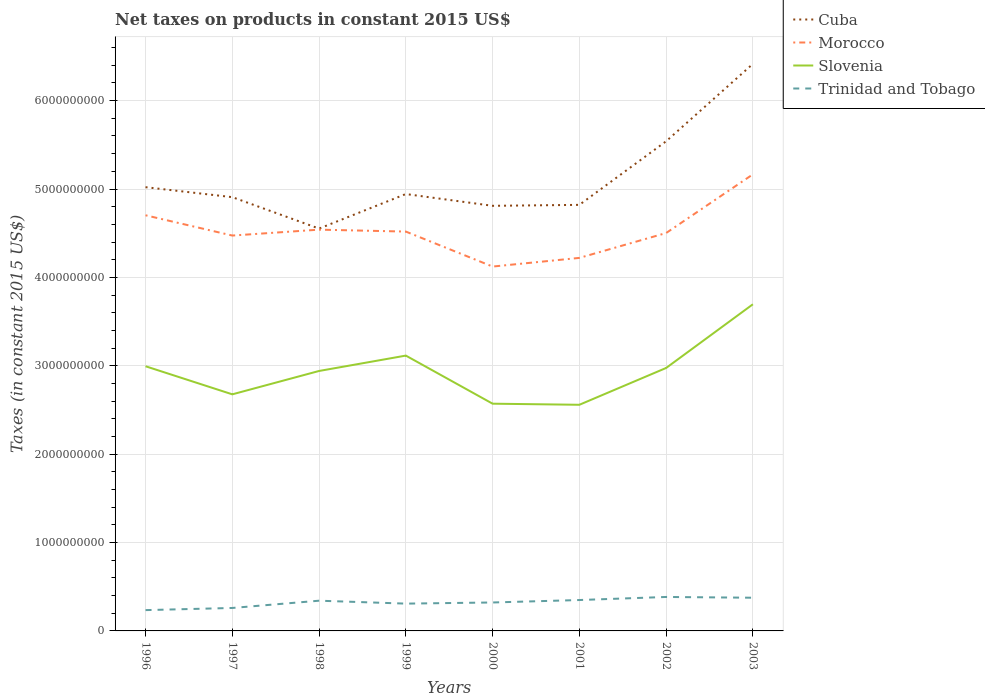How many different coloured lines are there?
Make the answer very short. 4. Does the line corresponding to Cuba intersect with the line corresponding to Trinidad and Tobago?
Ensure brevity in your answer.  No. Across all years, what is the maximum net taxes on products in Morocco?
Offer a very short reply. 4.12e+09. In which year was the net taxes on products in Slovenia maximum?
Your response must be concise. 2001. What is the total net taxes on products in Trinidad and Tobago in the graph?
Offer a terse response. -4.92e+07. What is the difference between the highest and the second highest net taxes on products in Trinidad and Tobago?
Offer a very short reply. 1.49e+08. Is the net taxes on products in Trinidad and Tobago strictly greater than the net taxes on products in Cuba over the years?
Your answer should be very brief. Yes. What is the difference between two consecutive major ticks on the Y-axis?
Provide a succinct answer. 1.00e+09. Are the values on the major ticks of Y-axis written in scientific E-notation?
Offer a terse response. No. Does the graph contain any zero values?
Your answer should be very brief. No. What is the title of the graph?
Your response must be concise. Net taxes on products in constant 2015 US$. Does "Korea (Republic)" appear as one of the legend labels in the graph?
Offer a terse response. No. What is the label or title of the X-axis?
Your answer should be very brief. Years. What is the label or title of the Y-axis?
Offer a terse response. Taxes (in constant 2015 US$). What is the Taxes (in constant 2015 US$) of Cuba in 1996?
Your answer should be very brief. 5.02e+09. What is the Taxes (in constant 2015 US$) of Morocco in 1996?
Your answer should be compact. 4.70e+09. What is the Taxes (in constant 2015 US$) in Slovenia in 1996?
Make the answer very short. 2.99e+09. What is the Taxes (in constant 2015 US$) of Trinidad and Tobago in 1996?
Make the answer very short. 2.35e+08. What is the Taxes (in constant 2015 US$) of Cuba in 1997?
Keep it short and to the point. 4.91e+09. What is the Taxes (in constant 2015 US$) of Morocco in 1997?
Provide a succinct answer. 4.47e+09. What is the Taxes (in constant 2015 US$) of Slovenia in 1997?
Offer a very short reply. 2.68e+09. What is the Taxes (in constant 2015 US$) of Trinidad and Tobago in 1997?
Ensure brevity in your answer.  2.60e+08. What is the Taxes (in constant 2015 US$) of Cuba in 1998?
Provide a short and direct response. 4.55e+09. What is the Taxes (in constant 2015 US$) of Morocco in 1998?
Provide a succinct answer. 4.54e+09. What is the Taxes (in constant 2015 US$) of Slovenia in 1998?
Give a very brief answer. 2.94e+09. What is the Taxes (in constant 2015 US$) of Trinidad and Tobago in 1998?
Provide a succinct answer. 3.42e+08. What is the Taxes (in constant 2015 US$) in Cuba in 1999?
Offer a very short reply. 4.94e+09. What is the Taxes (in constant 2015 US$) of Morocco in 1999?
Give a very brief answer. 4.52e+09. What is the Taxes (in constant 2015 US$) in Slovenia in 1999?
Your response must be concise. 3.12e+09. What is the Taxes (in constant 2015 US$) in Trinidad and Tobago in 1999?
Offer a very short reply. 3.09e+08. What is the Taxes (in constant 2015 US$) of Cuba in 2000?
Give a very brief answer. 4.81e+09. What is the Taxes (in constant 2015 US$) in Morocco in 2000?
Your response must be concise. 4.12e+09. What is the Taxes (in constant 2015 US$) in Slovenia in 2000?
Ensure brevity in your answer.  2.57e+09. What is the Taxes (in constant 2015 US$) in Trinidad and Tobago in 2000?
Give a very brief answer. 3.22e+08. What is the Taxes (in constant 2015 US$) in Cuba in 2001?
Provide a succinct answer. 4.82e+09. What is the Taxes (in constant 2015 US$) of Morocco in 2001?
Provide a succinct answer. 4.22e+09. What is the Taxes (in constant 2015 US$) of Slovenia in 2001?
Give a very brief answer. 2.56e+09. What is the Taxes (in constant 2015 US$) of Trinidad and Tobago in 2001?
Ensure brevity in your answer.  3.50e+08. What is the Taxes (in constant 2015 US$) in Cuba in 2002?
Your answer should be very brief. 5.54e+09. What is the Taxes (in constant 2015 US$) in Morocco in 2002?
Keep it short and to the point. 4.50e+09. What is the Taxes (in constant 2015 US$) of Slovenia in 2002?
Make the answer very short. 2.98e+09. What is the Taxes (in constant 2015 US$) of Trinidad and Tobago in 2002?
Make the answer very short. 3.84e+08. What is the Taxes (in constant 2015 US$) of Cuba in 2003?
Offer a very short reply. 6.42e+09. What is the Taxes (in constant 2015 US$) of Morocco in 2003?
Your answer should be very brief. 5.17e+09. What is the Taxes (in constant 2015 US$) in Slovenia in 2003?
Give a very brief answer. 3.70e+09. What is the Taxes (in constant 2015 US$) of Trinidad and Tobago in 2003?
Offer a terse response. 3.76e+08. Across all years, what is the maximum Taxes (in constant 2015 US$) in Cuba?
Offer a terse response. 6.42e+09. Across all years, what is the maximum Taxes (in constant 2015 US$) in Morocco?
Offer a very short reply. 5.17e+09. Across all years, what is the maximum Taxes (in constant 2015 US$) in Slovenia?
Ensure brevity in your answer.  3.70e+09. Across all years, what is the maximum Taxes (in constant 2015 US$) of Trinidad and Tobago?
Provide a succinct answer. 3.84e+08. Across all years, what is the minimum Taxes (in constant 2015 US$) in Cuba?
Give a very brief answer. 4.55e+09. Across all years, what is the minimum Taxes (in constant 2015 US$) in Morocco?
Offer a terse response. 4.12e+09. Across all years, what is the minimum Taxes (in constant 2015 US$) in Slovenia?
Keep it short and to the point. 2.56e+09. Across all years, what is the minimum Taxes (in constant 2015 US$) in Trinidad and Tobago?
Your answer should be very brief. 2.35e+08. What is the total Taxes (in constant 2015 US$) in Cuba in the graph?
Your response must be concise. 4.10e+1. What is the total Taxes (in constant 2015 US$) in Morocco in the graph?
Offer a terse response. 3.62e+1. What is the total Taxes (in constant 2015 US$) of Slovenia in the graph?
Offer a very short reply. 2.35e+1. What is the total Taxes (in constant 2015 US$) in Trinidad and Tobago in the graph?
Offer a terse response. 2.58e+09. What is the difference between the Taxes (in constant 2015 US$) in Cuba in 1996 and that in 1997?
Your response must be concise. 1.13e+08. What is the difference between the Taxes (in constant 2015 US$) in Morocco in 1996 and that in 1997?
Offer a very short reply. 2.29e+08. What is the difference between the Taxes (in constant 2015 US$) in Slovenia in 1996 and that in 1997?
Your answer should be compact. 3.18e+08. What is the difference between the Taxes (in constant 2015 US$) in Trinidad and Tobago in 1996 and that in 1997?
Make the answer very short. -2.43e+07. What is the difference between the Taxes (in constant 2015 US$) in Cuba in 1996 and that in 1998?
Provide a succinct answer. 4.68e+08. What is the difference between the Taxes (in constant 2015 US$) in Morocco in 1996 and that in 1998?
Keep it short and to the point. 1.63e+08. What is the difference between the Taxes (in constant 2015 US$) in Slovenia in 1996 and that in 1998?
Offer a very short reply. 5.34e+07. What is the difference between the Taxes (in constant 2015 US$) in Trinidad and Tobago in 1996 and that in 1998?
Provide a short and direct response. -1.07e+08. What is the difference between the Taxes (in constant 2015 US$) of Cuba in 1996 and that in 1999?
Your answer should be compact. 7.76e+07. What is the difference between the Taxes (in constant 2015 US$) in Morocco in 1996 and that in 1999?
Give a very brief answer. 1.85e+08. What is the difference between the Taxes (in constant 2015 US$) of Slovenia in 1996 and that in 1999?
Your response must be concise. -1.21e+08. What is the difference between the Taxes (in constant 2015 US$) in Trinidad and Tobago in 1996 and that in 1999?
Make the answer very short. -7.35e+07. What is the difference between the Taxes (in constant 2015 US$) in Cuba in 1996 and that in 2000?
Your answer should be compact. 2.11e+08. What is the difference between the Taxes (in constant 2015 US$) in Morocco in 1996 and that in 2000?
Your answer should be very brief. 5.80e+08. What is the difference between the Taxes (in constant 2015 US$) in Slovenia in 1996 and that in 2000?
Provide a short and direct response. 4.24e+08. What is the difference between the Taxes (in constant 2015 US$) of Trinidad and Tobago in 1996 and that in 2000?
Give a very brief answer. -8.63e+07. What is the difference between the Taxes (in constant 2015 US$) of Cuba in 1996 and that in 2001?
Offer a very short reply. 2.00e+08. What is the difference between the Taxes (in constant 2015 US$) of Morocco in 1996 and that in 2001?
Offer a terse response. 4.82e+08. What is the difference between the Taxes (in constant 2015 US$) of Slovenia in 1996 and that in 2001?
Offer a very short reply. 4.36e+08. What is the difference between the Taxes (in constant 2015 US$) of Trinidad and Tobago in 1996 and that in 2001?
Your response must be concise. -1.14e+08. What is the difference between the Taxes (in constant 2015 US$) of Cuba in 1996 and that in 2002?
Provide a succinct answer. -5.19e+08. What is the difference between the Taxes (in constant 2015 US$) of Morocco in 1996 and that in 2002?
Your answer should be compact. 2.01e+08. What is the difference between the Taxes (in constant 2015 US$) in Slovenia in 1996 and that in 2002?
Offer a terse response. 1.95e+07. What is the difference between the Taxes (in constant 2015 US$) of Trinidad and Tobago in 1996 and that in 2002?
Make the answer very short. -1.49e+08. What is the difference between the Taxes (in constant 2015 US$) of Cuba in 1996 and that in 2003?
Your answer should be compact. -1.40e+09. What is the difference between the Taxes (in constant 2015 US$) in Morocco in 1996 and that in 2003?
Keep it short and to the point. -4.63e+08. What is the difference between the Taxes (in constant 2015 US$) in Slovenia in 1996 and that in 2003?
Keep it short and to the point. -7.01e+08. What is the difference between the Taxes (in constant 2015 US$) of Trinidad and Tobago in 1996 and that in 2003?
Ensure brevity in your answer.  -1.40e+08. What is the difference between the Taxes (in constant 2015 US$) in Cuba in 1997 and that in 1998?
Your answer should be compact. 3.56e+08. What is the difference between the Taxes (in constant 2015 US$) in Morocco in 1997 and that in 1998?
Your response must be concise. -6.67e+07. What is the difference between the Taxes (in constant 2015 US$) in Slovenia in 1997 and that in 1998?
Make the answer very short. -2.64e+08. What is the difference between the Taxes (in constant 2015 US$) of Trinidad and Tobago in 1997 and that in 1998?
Your answer should be compact. -8.22e+07. What is the difference between the Taxes (in constant 2015 US$) of Cuba in 1997 and that in 1999?
Offer a very short reply. -3.52e+07. What is the difference between the Taxes (in constant 2015 US$) in Morocco in 1997 and that in 1999?
Give a very brief answer. -4.49e+07. What is the difference between the Taxes (in constant 2015 US$) in Slovenia in 1997 and that in 1999?
Your answer should be very brief. -4.38e+08. What is the difference between the Taxes (in constant 2015 US$) of Trinidad and Tobago in 1997 and that in 1999?
Give a very brief answer. -4.92e+07. What is the difference between the Taxes (in constant 2015 US$) in Cuba in 1997 and that in 2000?
Your answer should be very brief. 9.80e+07. What is the difference between the Taxes (in constant 2015 US$) in Morocco in 1997 and that in 2000?
Offer a very short reply. 3.51e+08. What is the difference between the Taxes (in constant 2015 US$) in Slovenia in 1997 and that in 2000?
Your answer should be very brief. 1.06e+08. What is the difference between the Taxes (in constant 2015 US$) in Trinidad and Tobago in 1997 and that in 2000?
Provide a short and direct response. -6.20e+07. What is the difference between the Taxes (in constant 2015 US$) in Cuba in 1997 and that in 2001?
Provide a short and direct response. 8.72e+07. What is the difference between the Taxes (in constant 2015 US$) in Morocco in 1997 and that in 2001?
Make the answer very short. 2.53e+08. What is the difference between the Taxes (in constant 2015 US$) in Slovenia in 1997 and that in 2001?
Your answer should be very brief. 1.18e+08. What is the difference between the Taxes (in constant 2015 US$) of Trinidad and Tobago in 1997 and that in 2001?
Your answer should be compact. -8.98e+07. What is the difference between the Taxes (in constant 2015 US$) in Cuba in 1997 and that in 2002?
Offer a terse response. -6.32e+08. What is the difference between the Taxes (in constant 2015 US$) of Morocco in 1997 and that in 2002?
Offer a very short reply. -2.85e+07. What is the difference between the Taxes (in constant 2015 US$) of Slovenia in 1997 and that in 2002?
Give a very brief answer. -2.98e+08. What is the difference between the Taxes (in constant 2015 US$) of Trinidad and Tobago in 1997 and that in 2002?
Provide a short and direct response. -1.24e+08. What is the difference between the Taxes (in constant 2015 US$) of Cuba in 1997 and that in 2003?
Offer a very short reply. -1.51e+09. What is the difference between the Taxes (in constant 2015 US$) in Morocco in 1997 and that in 2003?
Give a very brief answer. -6.92e+08. What is the difference between the Taxes (in constant 2015 US$) in Slovenia in 1997 and that in 2003?
Keep it short and to the point. -1.02e+09. What is the difference between the Taxes (in constant 2015 US$) of Trinidad and Tobago in 1997 and that in 2003?
Offer a very short reply. -1.16e+08. What is the difference between the Taxes (in constant 2015 US$) in Cuba in 1998 and that in 1999?
Your answer should be very brief. -3.91e+08. What is the difference between the Taxes (in constant 2015 US$) of Morocco in 1998 and that in 1999?
Your answer should be compact. 2.18e+07. What is the difference between the Taxes (in constant 2015 US$) in Slovenia in 1998 and that in 1999?
Provide a succinct answer. -1.74e+08. What is the difference between the Taxes (in constant 2015 US$) of Trinidad and Tobago in 1998 and that in 1999?
Provide a succinct answer. 3.30e+07. What is the difference between the Taxes (in constant 2015 US$) of Cuba in 1998 and that in 2000?
Offer a terse response. -2.58e+08. What is the difference between the Taxes (in constant 2015 US$) of Morocco in 1998 and that in 2000?
Offer a terse response. 4.18e+08. What is the difference between the Taxes (in constant 2015 US$) in Slovenia in 1998 and that in 2000?
Your response must be concise. 3.70e+08. What is the difference between the Taxes (in constant 2015 US$) in Trinidad and Tobago in 1998 and that in 2000?
Provide a succinct answer. 2.02e+07. What is the difference between the Taxes (in constant 2015 US$) in Cuba in 1998 and that in 2001?
Offer a very short reply. -2.68e+08. What is the difference between the Taxes (in constant 2015 US$) in Morocco in 1998 and that in 2001?
Make the answer very short. 3.20e+08. What is the difference between the Taxes (in constant 2015 US$) in Slovenia in 1998 and that in 2001?
Offer a terse response. 3.83e+08. What is the difference between the Taxes (in constant 2015 US$) of Trinidad and Tobago in 1998 and that in 2001?
Offer a terse response. -7.55e+06. What is the difference between the Taxes (in constant 2015 US$) in Cuba in 1998 and that in 2002?
Your answer should be compact. -9.88e+08. What is the difference between the Taxes (in constant 2015 US$) of Morocco in 1998 and that in 2002?
Keep it short and to the point. 3.82e+07. What is the difference between the Taxes (in constant 2015 US$) in Slovenia in 1998 and that in 2002?
Your response must be concise. -3.40e+07. What is the difference between the Taxes (in constant 2015 US$) of Trinidad and Tobago in 1998 and that in 2002?
Ensure brevity in your answer.  -4.22e+07. What is the difference between the Taxes (in constant 2015 US$) of Cuba in 1998 and that in 2003?
Make the answer very short. -1.86e+09. What is the difference between the Taxes (in constant 2015 US$) in Morocco in 1998 and that in 2003?
Your answer should be very brief. -6.26e+08. What is the difference between the Taxes (in constant 2015 US$) in Slovenia in 1998 and that in 2003?
Give a very brief answer. -7.55e+08. What is the difference between the Taxes (in constant 2015 US$) of Trinidad and Tobago in 1998 and that in 2003?
Give a very brief answer. -3.36e+07. What is the difference between the Taxes (in constant 2015 US$) of Cuba in 1999 and that in 2000?
Your answer should be very brief. 1.33e+08. What is the difference between the Taxes (in constant 2015 US$) of Morocco in 1999 and that in 2000?
Your answer should be very brief. 3.96e+08. What is the difference between the Taxes (in constant 2015 US$) of Slovenia in 1999 and that in 2000?
Provide a short and direct response. 5.44e+08. What is the difference between the Taxes (in constant 2015 US$) of Trinidad and Tobago in 1999 and that in 2000?
Provide a succinct answer. -1.29e+07. What is the difference between the Taxes (in constant 2015 US$) of Cuba in 1999 and that in 2001?
Keep it short and to the point. 1.22e+08. What is the difference between the Taxes (in constant 2015 US$) in Morocco in 1999 and that in 2001?
Your response must be concise. 2.98e+08. What is the difference between the Taxes (in constant 2015 US$) of Slovenia in 1999 and that in 2001?
Your answer should be very brief. 5.56e+08. What is the difference between the Taxes (in constant 2015 US$) of Trinidad and Tobago in 1999 and that in 2001?
Make the answer very short. -4.06e+07. What is the difference between the Taxes (in constant 2015 US$) in Cuba in 1999 and that in 2002?
Keep it short and to the point. -5.97e+08. What is the difference between the Taxes (in constant 2015 US$) of Morocco in 1999 and that in 2002?
Offer a terse response. 1.64e+07. What is the difference between the Taxes (in constant 2015 US$) of Slovenia in 1999 and that in 2002?
Make the answer very short. 1.40e+08. What is the difference between the Taxes (in constant 2015 US$) of Trinidad and Tobago in 1999 and that in 2002?
Your answer should be very brief. -7.53e+07. What is the difference between the Taxes (in constant 2015 US$) in Cuba in 1999 and that in 2003?
Your answer should be very brief. -1.47e+09. What is the difference between the Taxes (in constant 2015 US$) of Morocco in 1999 and that in 2003?
Keep it short and to the point. -6.48e+08. What is the difference between the Taxes (in constant 2015 US$) in Slovenia in 1999 and that in 2003?
Make the answer very short. -5.81e+08. What is the difference between the Taxes (in constant 2015 US$) in Trinidad and Tobago in 1999 and that in 2003?
Your response must be concise. -6.66e+07. What is the difference between the Taxes (in constant 2015 US$) of Cuba in 2000 and that in 2001?
Make the answer very short. -1.08e+07. What is the difference between the Taxes (in constant 2015 US$) in Morocco in 2000 and that in 2001?
Your answer should be compact. -9.79e+07. What is the difference between the Taxes (in constant 2015 US$) in Slovenia in 2000 and that in 2001?
Offer a terse response. 1.23e+07. What is the difference between the Taxes (in constant 2015 US$) in Trinidad and Tobago in 2000 and that in 2001?
Provide a short and direct response. -2.77e+07. What is the difference between the Taxes (in constant 2015 US$) of Cuba in 2000 and that in 2002?
Your response must be concise. -7.30e+08. What is the difference between the Taxes (in constant 2015 US$) of Morocco in 2000 and that in 2002?
Ensure brevity in your answer.  -3.79e+08. What is the difference between the Taxes (in constant 2015 US$) in Slovenia in 2000 and that in 2002?
Offer a very short reply. -4.04e+08. What is the difference between the Taxes (in constant 2015 US$) in Trinidad and Tobago in 2000 and that in 2002?
Ensure brevity in your answer.  -6.24e+07. What is the difference between the Taxes (in constant 2015 US$) in Cuba in 2000 and that in 2003?
Your answer should be very brief. -1.61e+09. What is the difference between the Taxes (in constant 2015 US$) of Morocco in 2000 and that in 2003?
Provide a short and direct response. -1.04e+09. What is the difference between the Taxes (in constant 2015 US$) in Slovenia in 2000 and that in 2003?
Give a very brief answer. -1.12e+09. What is the difference between the Taxes (in constant 2015 US$) in Trinidad and Tobago in 2000 and that in 2003?
Your answer should be compact. -5.38e+07. What is the difference between the Taxes (in constant 2015 US$) of Cuba in 2001 and that in 2002?
Make the answer very short. -7.19e+08. What is the difference between the Taxes (in constant 2015 US$) of Morocco in 2001 and that in 2002?
Keep it short and to the point. -2.81e+08. What is the difference between the Taxes (in constant 2015 US$) in Slovenia in 2001 and that in 2002?
Make the answer very short. -4.16e+08. What is the difference between the Taxes (in constant 2015 US$) of Trinidad and Tobago in 2001 and that in 2002?
Provide a succinct answer. -3.47e+07. What is the difference between the Taxes (in constant 2015 US$) of Cuba in 2001 and that in 2003?
Offer a terse response. -1.60e+09. What is the difference between the Taxes (in constant 2015 US$) of Morocco in 2001 and that in 2003?
Provide a short and direct response. -9.45e+08. What is the difference between the Taxes (in constant 2015 US$) of Slovenia in 2001 and that in 2003?
Provide a succinct answer. -1.14e+09. What is the difference between the Taxes (in constant 2015 US$) in Trinidad and Tobago in 2001 and that in 2003?
Ensure brevity in your answer.  -2.60e+07. What is the difference between the Taxes (in constant 2015 US$) of Cuba in 2002 and that in 2003?
Provide a short and direct response. -8.76e+08. What is the difference between the Taxes (in constant 2015 US$) of Morocco in 2002 and that in 2003?
Offer a very short reply. -6.64e+08. What is the difference between the Taxes (in constant 2015 US$) of Slovenia in 2002 and that in 2003?
Provide a succinct answer. -7.21e+08. What is the difference between the Taxes (in constant 2015 US$) of Trinidad and Tobago in 2002 and that in 2003?
Give a very brief answer. 8.65e+06. What is the difference between the Taxes (in constant 2015 US$) of Cuba in 1996 and the Taxes (in constant 2015 US$) of Morocco in 1997?
Your response must be concise. 5.47e+08. What is the difference between the Taxes (in constant 2015 US$) in Cuba in 1996 and the Taxes (in constant 2015 US$) in Slovenia in 1997?
Keep it short and to the point. 2.34e+09. What is the difference between the Taxes (in constant 2015 US$) of Cuba in 1996 and the Taxes (in constant 2015 US$) of Trinidad and Tobago in 1997?
Provide a short and direct response. 4.76e+09. What is the difference between the Taxes (in constant 2015 US$) of Morocco in 1996 and the Taxes (in constant 2015 US$) of Slovenia in 1997?
Your answer should be compact. 2.03e+09. What is the difference between the Taxes (in constant 2015 US$) in Morocco in 1996 and the Taxes (in constant 2015 US$) in Trinidad and Tobago in 1997?
Ensure brevity in your answer.  4.44e+09. What is the difference between the Taxes (in constant 2015 US$) of Slovenia in 1996 and the Taxes (in constant 2015 US$) of Trinidad and Tobago in 1997?
Provide a short and direct response. 2.73e+09. What is the difference between the Taxes (in constant 2015 US$) in Cuba in 1996 and the Taxes (in constant 2015 US$) in Morocco in 1998?
Ensure brevity in your answer.  4.80e+08. What is the difference between the Taxes (in constant 2015 US$) in Cuba in 1996 and the Taxes (in constant 2015 US$) in Slovenia in 1998?
Provide a succinct answer. 2.08e+09. What is the difference between the Taxes (in constant 2015 US$) of Cuba in 1996 and the Taxes (in constant 2015 US$) of Trinidad and Tobago in 1998?
Your answer should be compact. 4.68e+09. What is the difference between the Taxes (in constant 2015 US$) in Morocco in 1996 and the Taxes (in constant 2015 US$) in Slovenia in 1998?
Give a very brief answer. 1.76e+09. What is the difference between the Taxes (in constant 2015 US$) in Morocco in 1996 and the Taxes (in constant 2015 US$) in Trinidad and Tobago in 1998?
Provide a succinct answer. 4.36e+09. What is the difference between the Taxes (in constant 2015 US$) of Slovenia in 1996 and the Taxes (in constant 2015 US$) of Trinidad and Tobago in 1998?
Offer a very short reply. 2.65e+09. What is the difference between the Taxes (in constant 2015 US$) of Cuba in 1996 and the Taxes (in constant 2015 US$) of Morocco in 1999?
Offer a terse response. 5.02e+08. What is the difference between the Taxes (in constant 2015 US$) of Cuba in 1996 and the Taxes (in constant 2015 US$) of Slovenia in 1999?
Provide a succinct answer. 1.91e+09. What is the difference between the Taxes (in constant 2015 US$) in Cuba in 1996 and the Taxes (in constant 2015 US$) in Trinidad and Tobago in 1999?
Your answer should be very brief. 4.71e+09. What is the difference between the Taxes (in constant 2015 US$) of Morocco in 1996 and the Taxes (in constant 2015 US$) of Slovenia in 1999?
Offer a very short reply. 1.59e+09. What is the difference between the Taxes (in constant 2015 US$) in Morocco in 1996 and the Taxes (in constant 2015 US$) in Trinidad and Tobago in 1999?
Make the answer very short. 4.39e+09. What is the difference between the Taxes (in constant 2015 US$) in Slovenia in 1996 and the Taxes (in constant 2015 US$) in Trinidad and Tobago in 1999?
Provide a succinct answer. 2.69e+09. What is the difference between the Taxes (in constant 2015 US$) of Cuba in 1996 and the Taxes (in constant 2015 US$) of Morocco in 2000?
Your answer should be very brief. 8.98e+08. What is the difference between the Taxes (in constant 2015 US$) of Cuba in 1996 and the Taxes (in constant 2015 US$) of Slovenia in 2000?
Provide a succinct answer. 2.45e+09. What is the difference between the Taxes (in constant 2015 US$) in Cuba in 1996 and the Taxes (in constant 2015 US$) in Trinidad and Tobago in 2000?
Give a very brief answer. 4.70e+09. What is the difference between the Taxes (in constant 2015 US$) in Morocco in 1996 and the Taxes (in constant 2015 US$) in Slovenia in 2000?
Offer a terse response. 2.13e+09. What is the difference between the Taxes (in constant 2015 US$) in Morocco in 1996 and the Taxes (in constant 2015 US$) in Trinidad and Tobago in 2000?
Provide a short and direct response. 4.38e+09. What is the difference between the Taxes (in constant 2015 US$) in Slovenia in 1996 and the Taxes (in constant 2015 US$) in Trinidad and Tobago in 2000?
Ensure brevity in your answer.  2.67e+09. What is the difference between the Taxes (in constant 2015 US$) in Cuba in 1996 and the Taxes (in constant 2015 US$) in Morocco in 2001?
Ensure brevity in your answer.  8.00e+08. What is the difference between the Taxes (in constant 2015 US$) of Cuba in 1996 and the Taxes (in constant 2015 US$) of Slovenia in 2001?
Keep it short and to the point. 2.46e+09. What is the difference between the Taxes (in constant 2015 US$) of Cuba in 1996 and the Taxes (in constant 2015 US$) of Trinidad and Tobago in 2001?
Make the answer very short. 4.67e+09. What is the difference between the Taxes (in constant 2015 US$) of Morocco in 1996 and the Taxes (in constant 2015 US$) of Slovenia in 2001?
Ensure brevity in your answer.  2.14e+09. What is the difference between the Taxes (in constant 2015 US$) in Morocco in 1996 and the Taxes (in constant 2015 US$) in Trinidad and Tobago in 2001?
Give a very brief answer. 4.35e+09. What is the difference between the Taxes (in constant 2015 US$) of Slovenia in 1996 and the Taxes (in constant 2015 US$) of Trinidad and Tobago in 2001?
Provide a short and direct response. 2.65e+09. What is the difference between the Taxes (in constant 2015 US$) in Cuba in 1996 and the Taxes (in constant 2015 US$) in Morocco in 2002?
Your answer should be compact. 5.19e+08. What is the difference between the Taxes (in constant 2015 US$) of Cuba in 1996 and the Taxes (in constant 2015 US$) of Slovenia in 2002?
Your answer should be very brief. 2.05e+09. What is the difference between the Taxes (in constant 2015 US$) in Cuba in 1996 and the Taxes (in constant 2015 US$) in Trinidad and Tobago in 2002?
Give a very brief answer. 4.64e+09. What is the difference between the Taxes (in constant 2015 US$) in Morocco in 1996 and the Taxes (in constant 2015 US$) in Slovenia in 2002?
Your answer should be compact. 1.73e+09. What is the difference between the Taxes (in constant 2015 US$) in Morocco in 1996 and the Taxes (in constant 2015 US$) in Trinidad and Tobago in 2002?
Give a very brief answer. 4.32e+09. What is the difference between the Taxes (in constant 2015 US$) of Slovenia in 1996 and the Taxes (in constant 2015 US$) of Trinidad and Tobago in 2002?
Keep it short and to the point. 2.61e+09. What is the difference between the Taxes (in constant 2015 US$) of Cuba in 1996 and the Taxes (in constant 2015 US$) of Morocco in 2003?
Your response must be concise. -1.45e+08. What is the difference between the Taxes (in constant 2015 US$) in Cuba in 1996 and the Taxes (in constant 2015 US$) in Slovenia in 2003?
Your answer should be compact. 1.32e+09. What is the difference between the Taxes (in constant 2015 US$) of Cuba in 1996 and the Taxes (in constant 2015 US$) of Trinidad and Tobago in 2003?
Provide a short and direct response. 4.65e+09. What is the difference between the Taxes (in constant 2015 US$) of Morocco in 1996 and the Taxes (in constant 2015 US$) of Slovenia in 2003?
Your answer should be very brief. 1.01e+09. What is the difference between the Taxes (in constant 2015 US$) in Morocco in 1996 and the Taxes (in constant 2015 US$) in Trinidad and Tobago in 2003?
Make the answer very short. 4.33e+09. What is the difference between the Taxes (in constant 2015 US$) of Slovenia in 1996 and the Taxes (in constant 2015 US$) of Trinidad and Tobago in 2003?
Your answer should be very brief. 2.62e+09. What is the difference between the Taxes (in constant 2015 US$) of Cuba in 1997 and the Taxes (in constant 2015 US$) of Morocco in 1998?
Offer a terse response. 3.68e+08. What is the difference between the Taxes (in constant 2015 US$) in Cuba in 1997 and the Taxes (in constant 2015 US$) in Slovenia in 1998?
Your answer should be very brief. 1.97e+09. What is the difference between the Taxes (in constant 2015 US$) of Cuba in 1997 and the Taxes (in constant 2015 US$) of Trinidad and Tobago in 1998?
Provide a short and direct response. 4.57e+09. What is the difference between the Taxes (in constant 2015 US$) of Morocco in 1997 and the Taxes (in constant 2015 US$) of Slovenia in 1998?
Make the answer very short. 1.53e+09. What is the difference between the Taxes (in constant 2015 US$) in Morocco in 1997 and the Taxes (in constant 2015 US$) in Trinidad and Tobago in 1998?
Ensure brevity in your answer.  4.13e+09. What is the difference between the Taxes (in constant 2015 US$) of Slovenia in 1997 and the Taxes (in constant 2015 US$) of Trinidad and Tobago in 1998?
Offer a terse response. 2.33e+09. What is the difference between the Taxes (in constant 2015 US$) in Cuba in 1997 and the Taxes (in constant 2015 US$) in Morocco in 1999?
Your response must be concise. 3.90e+08. What is the difference between the Taxes (in constant 2015 US$) of Cuba in 1997 and the Taxes (in constant 2015 US$) of Slovenia in 1999?
Give a very brief answer. 1.79e+09. What is the difference between the Taxes (in constant 2015 US$) of Cuba in 1997 and the Taxes (in constant 2015 US$) of Trinidad and Tobago in 1999?
Ensure brevity in your answer.  4.60e+09. What is the difference between the Taxes (in constant 2015 US$) in Morocco in 1997 and the Taxes (in constant 2015 US$) in Slovenia in 1999?
Offer a terse response. 1.36e+09. What is the difference between the Taxes (in constant 2015 US$) in Morocco in 1997 and the Taxes (in constant 2015 US$) in Trinidad and Tobago in 1999?
Offer a very short reply. 4.16e+09. What is the difference between the Taxes (in constant 2015 US$) of Slovenia in 1997 and the Taxes (in constant 2015 US$) of Trinidad and Tobago in 1999?
Provide a short and direct response. 2.37e+09. What is the difference between the Taxes (in constant 2015 US$) in Cuba in 1997 and the Taxes (in constant 2015 US$) in Morocco in 2000?
Your response must be concise. 7.85e+08. What is the difference between the Taxes (in constant 2015 US$) of Cuba in 1997 and the Taxes (in constant 2015 US$) of Slovenia in 2000?
Provide a short and direct response. 2.34e+09. What is the difference between the Taxes (in constant 2015 US$) of Cuba in 1997 and the Taxes (in constant 2015 US$) of Trinidad and Tobago in 2000?
Your answer should be very brief. 4.59e+09. What is the difference between the Taxes (in constant 2015 US$) of Morocco in 1997 and the Taxes (in constant 2015 US$) of Slovenia in 2000?
Your response must be concise. 1.90e+09. What is the difference between the Taxes (in constant 2015 US$) of Morocco in 1997 and the Taxes (in constant 2015 US$) of Trinidad and Tobago in 2000?
Offer a very short reply. 4.15e+09. What is the difference between the Taxes (in constant 2015 US$) in Slovenia in 1997 and the Taxes (in constant 2015 US$) in Trinidad and Tobago in 2000?
Offer a very short reply. 2.36e+09. What is the difference between the Taxes (in constant 2015 US$) in Cuba in 1997 and the Taxes (in constant 2015 US$) in Morocco in 2001?
Your answer should be compact. 6.87e+08. What is the difference between the Taxes (in constant 2015 US$) in Cuba in 1997 and the Taxes (in constant 2015 US$) in Slovenia in 2001?
Your answer should be compact. 2.35e+09. What is the difference between the Taxes (in constant 2015 US$) in Cuba in 1997 and the Taxes (in constant 2015 US$) in Trinidad and Tobago in 2001?
Your response must be concise. 4.56e+09. What is the difference between the Taxes (in constant 2015 US$) in Morocco in 1997 and the Taxes (in constant 2015 US$) in Slovenia in 2001?
Provide a succinct answer. 1.91e+09. What is the difference between the Taxes (in constant 2015 US$) in Morocco in 1997 and the Taxes (in constant 2015 US$) in Trinidad and Tobago in 2001?
Offer a very short reply. 4.12e+09. What is the difference between the Taxes (in constant 2015 US$) of Slovenia in 1997 and the Taxes (in constant 2015 US$) of Trinidad and Tobago in 2001?
Your response must be concise. 2.33e+09. What is the difference between the Taxes (in constant 2015 US$) in Cuba in 1997 and the Taxes (in constant 2015 US$) in Morocco in 2002?
Your answer should be compact. 4.06e+08. What is the difference between the Taxes (in constant 2015 US$) of Cuba in 1997 and the Taxes (in constant 2015 US$) of Slovenia in 2002?
Your answer should be compact. 1.93e+09. What is the difference between the Taxes (in constant 2015 US$) of Cuba in 1997 and the Taxes (in constant 2015 US$) of Trinidad and Tobago in 2002?
Give a very brief answer. 4.52e+09. What is the difference between the Taxes (in constant 2015 US$) of Morocco in 1997 and the Taxes (in constant 2015 US$) of Slovenia in 2002?
Offer a terse response. 1.50e+09. What is the difference between the Taxes (in constant 2015 US$) in Morocco in 1997 and the Taxes (in constant 2015 US$) in Trinidad and Tobago in 2002?
Offer a terse response. 4.09e+09. What is the difference between the Taxes (in constant 2015 US$) in Slovenia in 1997 and the Taxes (in constant 2015 US$) in Trinidad and Tobago in 2002?
Provide a succinct answer. 2.29e+09. What is the difference between the Taxes (in constant 2015 US$) of Cuba in 1997 and the Taxes (in constant 2015 US$) of Morocco in 2003?
Your response must be concise. -2.58e+08. What is the difference between the Taxes (in constant 2015 US$) in Cuba in 1997 and the Taxes (in constant 2015 US$) in Slovenia in 2003?
Keep it short and to the point. 1.21e+09. What is the difference between the Taxes (in constant 2015 US$) in Cuba in 1997 and the Taxes (in constant 2015 US$) in Trinidad and Tobago in 2003?
Provide a succinct answer. 4.53e+09. What is the difference between the Taxes (in constant 2015 US$) in Morocco in 1997 and the Taxes (in constant 2015 US$) in Slovenia in 2003?
Offer a terse response. 7.78e+08. What is the difference between the Taxes (in constant 2015 US$) in Morocco in 1997 and the Taxes (in constant 2015 US$) in Trinidad and Tobago in 2003?
Provide a succinct answer. 4.10e+09. What is the difference between the Taxes (in constant 2015 US$) in Slovenia in 1997 and the Taxes (in constant 2015 US$) in Trinidad and Tobago in 2003?
Offer a very short reply. 2.30e+09. What is the difference between the Taxes (in constant 2015 US$) of Cuba in 1998 and the Taxes (in constant 2015 US$) of Morocco in 1999?
Offer a very short reply. 3.39e+07. What is the difference between the Taxes (in constant 2015 US$) in Cuba in 1998 and the Taxes (in constant 2015 US$) in Slovenia in 1999?
Keep it short and to the point. 1.44e+09. What is the difference between the Taxes (in constant 2015 US$) of Cuba in 1998 and the Taxes (in constant 2015 US$) of Trinidad and Tobago in 1999?
Your response must be concise. 4.24e+09. What is the difference between the Taxes (in constant 2015 US$) in Morocco in 1998 and the Taxes (in constant 2015 US$) in Slovenia in 1999?
Offer a terse response. 1.42e+09. What is the difference between the Taxes (in constant 2015 US$) in Morocco in 1998 and the Taxes (in constant 2015 US$) in Trinidad and Tobago in 1999?
Your answer should be very brief. 4.23e+09. What is the difference between the Taxes (in constant 2015 US$) in Slovenia in 1998 and the Taxes (in constant 2015 US$) in Trinidad and Tobago in 1999?
Your answer should be compact. 2.63e+09. What is the difference between the Taxes (in constant 2015 US$) of Cuba in 1998 and the Taxes (in constant 2015 US$) of Morocco in 2000?
Your response must be concise. 4.30e+08. What is the difference between the Taxes (in constant 2015 US$) in Cuba in 1998 and the Taxes (in constant 2015 US$) in Slovenia in 2000?
Your answer should be very brief. 1.98e+09. What is the difference between the Taxes (in constant 2015 US$) of Cuba in 1998 and the Taxes (in constant 2015 US$) of Trinidad and Tobago in 2000?
Your answer should be very brief. 4.23e+09. What is the difference between the Taxes (in constant 2015 US$) of Morocco in 1998 and the Taxes (in constant 2015 US$) of Slovenia in 2000?
Keep it short and to the point. 1.97e+09. What is the difference between the Taxes (in constant 2015 US$) in Morocco in 1998 and the Taxes (in constant 2015 US$) in Trinidad and Tobago in 2000?
Offer a terse response. 4.22e+09. What is the difference between the Taxes (in constant 2015 US$) of Slovenia in 1998 and the Taxes (in constant 2015 US$) of Trinidad and Tobago in 2000?
Give a very brief answer. 2.62e+09. What is the difference between the Taxes (in constant 2015 US$) of Cuba in 1998 and the Taxes (in constant 2015 US$) of Morocco in 2001?
Give a very brief answer. 3.32e+08. What is the difference between the Taxes (in constant 2015 US$) in Cuba in 1998 and the Taxes (in constant 2015 US$) in Slovenia in 2001?
Make the answer very short. 1.99e+09. What is the difference between the Taxes (in constant 2015 US$) in Cuba in 1998 and the Taxes (in constant 2015 US$) in Trinidad and Tobago in 2001?
Offer a terse response. 4.20e+09. What is the difference between the Taxes (in constant 2015 US$) in Morocco in 1998 and the Taxes (in constant 2015 US$) in Slovenia in 2001?
Ensure brevity in your answer.  1.98e+09. What is the difference between the Taxes (in constant 2015 US$) of Morocco in 1998 and the Taxes (in constant 2015 US$) of Trinidad and Tobago in 2001?
Offer a terse response. 4.19e+09. What is the difference between the Taxes (in constant 2015 US$) of Slovenia in 1998 and the Taxes (in constant 2015 US$) of Trinidad and Tobago in 2001?
Keep it short and to the point. 2.59e+09. What is the difference between the Taxes (in constant 2015 US$) in Cuba in 1998 and the Taxes (in constant 2015 US$) in Morocco in 2002?
Give a very brief answer. 5.03e+07. What is the difference between the Taxes (in constant 2015 US$) in Cuba in 1998 and the Taxes (in constant 2015 US$) in Slovenia in 2002?
Give a very brief answer. 1.58e+09. What is the difference between the Taxes (in constant 2015 US$) in Cuba in 1998 and the Taxes (in constant 2015 US$) in Trinidad and Tobago in 2002?
Your response must be concise. 4.17e+09. What is the difference between the Taxes (in constant 2015 US$) of Morocco in 1998 and the Taxes (in constant 2015 US$) of Slovenia in 2002?
Keep it short and to the point. 1.56e+09. What is the difference between the Taxes (in constant 2015 US$) of Morocco in 1998 and the Taxes (in constant 2015 US$) of Trinidad and Tobago in 2002?
Offer a very short reply. 4.16e+09. What is the difference between the Taxes (in constant 2015 US$) in Slovenia in 1998 and the Taxes (in constant 2015 US$) in Trinidad and Tobago in 2002?
Keep it short and to the point. 2.56e+09. What is the difference between the Taxes (in constant 2015 US$) in Cuba in 1998 and the Taxes (in constant 2015 US$) in Morocco in 2003?
Offer a terse response. -6.14e+08. What is the difference between the Taxes (in constant 2015 US$) of Cuba in 1998 and the Taxes (in constant 2015 US$) of Slovenia in 2003?
Offer a terse response. 8.56e+08. What is the difference between the Taxes (in constant 2015 US$) of Cuba in 1998 and the Taxes (in constant 2015 US$) of Trinidad and Tobago in 2003?
Provide a succinct answer. 4.18e+09. What is the difference between the Taxes (in constant 2015 US$) in Morocco in 1998 and the Taxes (in constant 2015 US$) in Slovenia in 2003?
Your answer should be very brief. 8.44e+08. What is the difference between the Taxes (in constant 2015 US$) of Morocco in 1998 and the Taxes (in constant 2015 US$) of Trinidad and Tobago in 2003?
Offer a very short reply. 4.16e+09. What is the difference between the Taxes (in constant 2015 US$) of Slovenia in 1998 and the Taxes (in constant 2015 US$) of Trinidad and Tobago in 2003?
Ensure brevity in your answer.  2.57e+09. What is the difference between the Taxes (in constant 2015 US$) of Cuba in 1999 and the Taxes (in constant 2015 US$) of Morocco in 2000?
Your answer should be compact. 8.20e+08. What is the difference between the Taxes (in constant 2015 US$) in Cuba in 1999 and the Taxes (in constant 2015 US$) in Slovenia in 2000?
Offer a terse response. 2.37e+09. What is the difference between the Taxes (in constant 2015 US$) of Cuba in 1999 and the Taxes (in constant 2015 US$) of Trinidad and Tobago in 2000?
Provide a short and direct response. 4.62e+09. What is the difference between the Taxes (in constant 2015 US$) of Morocco in 1999 and the Taxes (in constant 2015 US$) of Slovenia in 2000?
Your answer should be compact. 1.95e+09. What is the difference between the Taxes (in constant 2015 US$) of Morocco in 1999 and the Taxes (in constant 2015 US$) of Trinidad and Tobago in 2000?
Make the answer very short. 4.20e+09. What is the difference between the Taxes (in constant 2015 US$) in Slovenia in 1999 and the Taxes (in constant 2015 US$) in Trinidad and Tobago in 2000?
Your answer should be very brief. 2.79e+09. What is the difference between the Taxes (in constant 2015 US$) of Cuba in 1999 and the Taxes (in constant 2015 US$) of Morocco in 2001?
Provide a short and direct response. 7.23e+08. What is the difference between the Taxes (in constant 2015 US$) in Cuba in 1999 and the Taxes (in constant 2015 US$) in Slovenia in 2001?
Your answer should be very brief. 2.38e+09. What is the difference between the Taxes (in constant 2015 US$) of Cuba in 1999 and the Taxes (in constant 2015 US$) of Trinidad and Tobago in 2001?
Provide a succinct answer. 4.59e+09. What is the difference between the Taxes (in constant 2015 US$) in Morocco in 1999 and the Taxes (in constant 2015 US$) in Slovenia in 2001?
Your response must be concise. 1.96e+09. What is the difference between the Taxes (in constant 2015 US$) in Morocco in 1999 and the Taxes (in constant 2015 US$) in Trinidad and Tobago in 2001?
Offer a very short reply. 4.17e+09. What is the difference between the Taxes (in constant 2015 US$) in Slovenia in 1999 and the Taxes (in constant 2015 US$) in Trinidad and Tobago in 2001?
Make the answer very short. 2.77e+09. What is the difference between the Taxes (in constant 2015 US$) of Cuba in 1999 and the Taxes (in constant 2015 US$) of Morocco in 2002?
Keep it short and to the point. 4.41e+08. What is the difference between the Taxes (in constant 2015 US$) of Cuba in 1999 and the Taxes (in constant 2015 US$) of Slovenia in 2002?
Offer a terse response. 1.97e+09. What is the difference between the Taxes (in constant 2015 US$) of Cuba in 1999 and the Taxes (in constant 2015 US$) of Trinidad and Tobago in 2002?
Make the answer very short. 4.56e+09. What is the difference between the Taxes (in constant 2015 US$) of Morocco in 1999 and the Taxes (in constant 2015 US$) of Slovenia in 2002?
Make the answer very short. 1.54e+09. What is the difference between the Taxes (in constant 2015 US$) in Morocco in 1999 and the Taxes (in constant 2015 US$) in Trinidad and Tobago in 2002?
Offer a terse response. 4.13e+09. What is the difference between the Taxes (in constant 2015 US$) of Slovenia in 1999 and the Taxes (in constant 2015 US$) of Trinidad and Tobago in 2002?
Ensure brevity in your answer.  2.73e+09. What is the difference between the Taxes (in constant 2015 US$) of Cuba in 1999 and the Taxes (in constant 2015 US$) of Morocco in 2003?
Offer a very short reply. -2.23e+08. What is the difference between the Taxes (in constant 2015 US$) of Cuba in 1999 and the Taxes (in constant 2015 US$) of Slovenia in 2003?
Your answer should be very brief. 1.25e+09. What is the difference between the Taxes (in constant 2015 US$) of Cuba in 1999 and the Taxes (in constant 2015 US$) of Trinidad and Tobago in 2003?
Make the answer very short. 4.57e+09. What is the difference between the Taxes (in constant 2015 US$) in Morocco in 1999 and the Taxes (in constant 2015 US$) in Slovenia in 2003?
Provide a succinct answer. 8.23e+08. What is the difference between the Taxes (in constant 2015 US$) of Morocco in 1999 and the Taxes (in constant 2015 US$) of Trinidad and Tobago in 2003?
Your answer should be compact. 4.14e+09. What is the difference between the Taxes (in constant 2015 US$) of Slovenia in 1999 and the Taxes (in constant 2015 US$) of Trinidad and Tobago in 2003?
Offer a terse response. 2.74e+09. What is the difference between the Taxes (in constant 2015 US$) in Cuba in 2000 and the Taxes (in constant 2015 US$) in Morocco in 2001?
Make the answer very short. 5.89e+08. What is the difference between the Taxes (in constant 2015 US$) of Cuba in 2000 and the Taxes (in constant 2015 US$) of Slovenia in 2001?
Provide a short and direct response. 2.25e+09. What is the difference between the Taxes (in constant 2015 US$) in Cuba in 2000 and the Taxes (in constant 2015 US$) in Trinidad and Tobago in 2001?
Provide a succinct answer. 4.46e+09. What is the difference between the Taxes (in constant 2015 US$) in Morocco in 2000 and the Taxes (in constant 2015 US$) in Slovenia in 2001?
Your answer should be compact. 1.56e+09. What is the difference between the Taxes (in constant 2015 US$) of Morocco in 2000 and the Taxes (in constant 2015 US$) of Trinidad and Tobago in 2001?
Provide a short and direct response. 3.77e+09. What is the difference between the Taxes (in constant 2015 US$) in Slovenia in 2000 and the Taxes (in constant 2015 US$) in Trinidad and Tobago in 2001?
Your answer should be compact. 2.22e+09. What is the difference between the Taxes (in constant 2015 US$) in Cuba in 2000 and the Taxes (in constant 2015 US$) in Morocco in 2002?
Make the answer very short. 3.08e+08. What is the difference between the Taxes (in constant 2015 US$) of Cuba in 2000 and the Taxes (in constant 2015 US$) of Slovenia in 2002?
Ensure brevity in your answer.  1.83e+09. What is the difference between the Taxes (in constant 2015 US$) of Cuba in 2000 and the Taxes (in constant 2015 US$) of Trinidad and Tobago in 2002?
Offer a very short reply. 4.43e+09. What is the difference between the Taxes (in constant 2015 US$) in Morocco in 2000 and the Taxes (in constant 2015 US$) in Slovenia in 2002?
Keep it short and to the point. 1.15e+09. What is the difference between the Taxes (in constant 2015 US$) in Morocco in 2000 and the Taxes (in constant 2015 US$) in Trinidad and Tobago in 2002?
Your response must be concise. 3.74e+09. What is the difference between the Taxes (in constant 2015 US$) in Slovenia in 2000 and the Taxes (in constant 2015 US$) in Trinidad and Tobago in 2002?
Your response must be concise. 2.19e+09. What is the difference between the Taxes (in constant 2015 US$) of Cuba in 2000 and the Taxes (in constant 2015 US$) of Morocco in 2003?
Keep it short and to the point. -3.56e+08. What is the difference between the Taxes (in constant 2015 US$) in Cuba in 2000 and the Taxes (in constant 2015 US$) in Slovenia in 2003?
Provide a succinct answer. 1.11e+09. What is the difference between the Taxes (in constant 2015 US$) of Cuba in 2000 and the Taxes (in constant 2015 US$) of Trinidad and Tobago in 2003?
Your answer should be very brief. 4.43e+09. What is the difference between the Taxes (in constant 2015 US$) in Morocco in 2000 and the Taxes (in constant 2015 US$) in Slovenia in 2003?
Provide a short and direct response. 4.27e+08. What is the difference between the Taxes (in constant 2015 US$) in Morocco in 2000 and the Taxes (in constant 2015 US$) in Trinidad and Tobago in 2003?
Your answer should be compact. 3.75e+09. What is the difference between the Taxes (in constant 2015 US$) in Slovenia in 2000 and the Taxes (in constant 2015 US$) in Trinidad and Tobago in 2003?
Offer a terse response. 2.20e+09. What is the difference between the Taxes (in constant 2015 US$) of Cuba in 2001 and the Taxes (in constant 2015 US$) of Morocco in 2002?
Make the answer very short. 3.19e+08. What is the difference between the Taxes (in constant 2015 US$) of Cuba in 2001 and the Taxes (in constant 2015 US$) of Slovenia in 2002?
Give a very brief answer. 1.85e+09. What is the difference between the Taxes (in constant 2015 US$) in Cuba in 2001 and the Taxes (in constant 2015 US$) in Trinidad and Tobago in 2002?
Offer a terse response. 4.44e+09. What is the difference between the Taxes (in constant 2015 US$) of Morocco in 2001 and the Taxes (in constant 2015 US$) of Slovenia in 2002?
Make the answer very short. 1.25e+09. What is the difference between the Taxes (in constant 2015 US$) of Morocco in 2001 and the Taxes (in constant 2015 US$) of Trinidad and Tobago in 2002?
Give a very brief answer. 3.84e+09. What is the difference between the Taxes (in constant 2015 US$) in Slovenia in 2001 and the Taxes (in constant 2015 US$) in Trinidad and Tobago in 2002?
Offer a terse response. 2.17e+09. What is the difference between the Taxes (in constant 2015 US$) in Cuba in 2001 and the Taxes (in constant 2015 US$) in Morocco in 2003?
Ensure brevity in your answer.  -3.45e+08. What is the difference between the Taxes (in constant 2015 US$) of Cuba in 2001 and the Taxes (in constant 2015 US$) of Slovenia in 2003?
Keep it short and to the point. 1.12e+09. What is the difference between the Taxes (in constant 2015 US$) of Cuba in 2001 and the Taxes (in constant 2015 US$) of Trinidad and Tobago in 2003?
Give a very brief answer. 4.45e+09. What is the difference between the Taxes (in constant 2015 US$) of Morocco in 2001 and the Taxes (in constant 2015 US$) of Slovenia in 2003?
Keep it short and to the point. 5.25e+08. What is the difference between the Taxes (in constant 2015 US$) of Morocco in 2001 and the Taxes (in constant 2015 US$) of Trinidad and Tobago in 2003?
Provide a succinct answer. 3.84e+09. What is the difference between the Taxes (in constant 2015 US$) of Slovenia in 2001 and the Taxes (in constant 2015 US$) of Trinidad and Tobago in 2003?
Your answer should be compact. 2.18e+09. What is the difference between the Taxes (in constant 2015 US$) in Cuba in 2002 and the Taxes (in constant 2015 US$) in Morocco in 2003?
Provide a short and direct response. 3.74e+08. What is the difference between the Taxes (in constant 2015 US$) of Cuba in 2002 and the Taxes (in constant 2015 US$) of Slovenia in 2003?
Your answer should be very brief. 1.84e+09. What is the difference between the Taxes (in constant 2015 US$) of Cuba in 2002 and the Taxes (in constant 2015 US$) of Trinidad and Tobago in 2003?
Make the answer very short. 5.16e+09. What is the difference between the Taxes (in constant 2015 US$) in Morocco in 2002 and the Taxes (in constant 2015 US$) in Slovenia in 2003?
Your response must be concise. 8.06e+08. What is the difference between the Taxes (in constant 2015 US$) in Morocco in 2002 and the Taxes (in constant 2015 US$) in Trinidad and Tobago in 2003?
Your answer should be compact. 4.13e+09. What is the difference between the Taxes (in constant 2015 US$) in Slovenia in 2002 and the Taxes (in constant 2015 US$) in Trinidad and Tobago in 2003?
Your answer should be very brief. 2.60e+09. What is the average Taxes (in constant 2015 US$) in Cuba per year?
Ensure brevity in your answer.  5.13e+09. What is the average Taxes (in constant 2015 US$) of Morocco per year?
Provide a succinct answer. 4.53e+09. What is the average Taxes (in constant 2015 US$) in Slovenia per year?
Keep it short and to the point. 2.94e+09. What is the average Taxes (in constant 2015 US$) in Trinidad and Tobago per year?
Give a very brief answer. 3.22e+08. In the year 1996, what is the difference between the Taxes (in constant 2015 US$) of Cuba and Taxes (in constant 2015 US$) of Morocco?
Your response must be concise. 3.18e+08. In the year 1996, what is the difference between the Taxes (in constant 2015 US$) in Cuba and Taxes (in constant 2015 US$) in Slovenia?
Your response must be concise. 2.03e+09. In the year 1996, what is the difference between the Taxes (in constant 2015 US$) in Cuba and Taxes (in constant 2015 US$) in Trinidad and Tobago?
Your answer should be very brief. 4.79e+09. In the year 1996, what is the difference between the Taxes (in constant 2015 US$) of Morocco and Taxes (in constant 2015 US$) of Slovenia?
Provide a short and direct response. 1.71e+09. In the year 1996, what is the difference between the Taxes (in constant 2015 US$) in Morocco and Taxes (in constant 2015 US$) in Trinidad and Tobago?
Your answer should be compact. 4.47e+09. In the year 1996, what is the difference between the Taxes (in constant 2015 US$) of Slovenia and Taxes (in constant 2015 US$) of Trinidad and Tobago?
Your answer should be very brief. 2.76e+09. In the year 1997, what is the difference between the Taxes (in constant 2015 US$) in Cuba and Taxes (in constant 2015 US$) in Morocco?
Your response must be concise. 4.34e+08. In the year 1997, what is the difference between the Taxes (in constant 2015 US$) in Cuba and Taxes (in constant 2015 US$) in Slovenia?
Ensure brevity in your answer.  2.23e+09. In the year 1997, what is the difference between the Taxes (in constant 2015 US$) of Cuba and Taxes (in constant 2015 US$) of Trinidad and Tobago?
Keep it short and to the point. 4.65e+09. In the year 1997, what is the difference between the Taxes (in constant 2015 US$) in Morocco and Taxes (in constant 2015 US$) in Slovenia?
Give a very brief answer. 1.80e+09. In the year 1997, what is the difference between the Taxes (in constant 2015 US$) of Morocco and Taxes (in constant 2015 US$) of Trinidad and Tobago?
Ensure brevity in your answer.  4.21e+09. In the year 1997, what is the difference between the Taxes (in constant 2015 US$) in Slovenia and Taxes (in constant 2015 US$) in Trinidad and Tobago?
Give a very brief answer. 2.42e+09. In the year 1998, what is the difference between the Taxes (in constant 2015 US$) in Cuba and Taxes (in constant 2015 US$) in Morocco?
Your answer should be very brief. 1.21e+07. In the year 1998, what is the difference between the Taxes (in constant 2015 US$) in Cuba and Taxes (in constant 2015 US$) in Slovenia?
Your response must be concise. 1.61e+09. In the year 1998, what is the difference between the Taxes (in constant 2015 US$) of Cuba and Taxes (in constant 2015 US$) of Trinidad and Tobago?
Your response must be concise. 4.21e+09. In the year 1998, what is the difference between the Taxes (in constant 2015 US$) of Morocco and Taxes (in constant 2015 US$) of Slovenia?
Keep it short and to the point. 1.60e+09. In the year 1998, what is the difference between the Taxes (in constant 2015 US$) of Morocco and Taxes (in constant 2015 US$) of Trinidad and Tobago?
Offer a terse response. 4.20e+09. In the year 1998, what is the difference between the Taxes (in constant 2015 US$) in Slovenia and Taxes (in constant 2015 US$) in Trinidad and Tobago?
Your answer should be compact. 2.60e+09. In the year 1999, what is the difference between the Taxes (in constant 2015 US$) in Cuba and Taxes (in constant 2015 US$) in Morocco?
Provide a short and direct response. 4.25e+08. In the year 1999, what is the difference between the Taxes (in constant 2015 US$) of Cuba and Taxes (in constant 2015 US$) of Slovenia?
Keep it short and to the point. 1.83e+09. In the year 1999, what is the difference between the Taxes (in constant 2015 US$) of Cuba and Taxes (in constant 2015 US$) of Trinidad and Tobago?
Provide a short and direct response. 4.63e+09. In the year 1999, what is the difference between the Taxes (in constant 2015 US$) in Morocco and Taxes (in constant 2015 US$) in Slovenia?
Your response must be concise. 1.40e+09. In the year 1999, what is the difference between the Taxes (in constant 2015 US$) in Morocco and Taxes (in constant 2015 US$) in Trinidad and Tobago?
Keep it short and to the point. 4.21e+09. In the year 1999, what is the difference between the Taxes (in constant 2015 US$) in Slovenia and Taxes (in constant 2015 US$) in Trinidad and Tobago?
Ensure brevity in your answer.  2.81e+09. In the year 2000, what is the difference between the Taxes (in constant 2015 US$) in Cuba and Taxes (in constant 2015 US$) in Morocco?
Offer a terse response. 6.87e+08. In the year 2000, what is the difference between the Taxes (in constant 2015 US$) of Cuba and Taxes (in constant 2015 US$) of Slovenia?
Keep it short and to the point. 2.24e+09. In the year 2000, what is the difference between the Taxes (in constant 2015 US$) of Cuba and Taxes (in constant 2015 US$) of Trinidad and Tobago?
Ensure brevity in your answer.  4.49e+09. In the year 2000, what is the difference between the Taxes (in constant 2015 US$) in Morocco and Taxes (in constant 2015 US$) in Slovenia?
Provide a short and direct response. 1.55e+09. In the year 2000, what is the difference between the Taxes (in constant 2015 US$) in Morocco and Taxes (in constant 2015 US$) in Trinidad and Tobago?
Provide a succinct answer. 3.80e+09. In the year 2000, what is the difference between the Taxes (in constant 2015 US$) of Slovenia and Taxes (in constant 2015 US$) of Trinidad and Tobago?
Keep it short and to the point. 2.25e+09. In the year 2001, what is the difference between the Taxes (in constant 2015 US$) of Cuba and Taxes (in constant 2015 US$) of Morocco?
Offer a terse response. 6.00e+08. In the year 2001, what is the difference between the Taxes (in constant 2015 US$) of Cuba and Taxes (in constant 2015 US$) of Slovenia?
Your response must be concise. 2.26e+09. In the year 2001, what is the difference between the Taxes (in constant 2015 US$) of Cuba and Taxes (in constant 2015 US$) of Trinidad and Tobago?
Your response must be concise. 4.47e+09. In the year 2001, what is the difference between the Taxes (in constant 2015 US$) of Morocco and Taxes (in constant 2015 US$) of Slovenia?
Provide a succinct answer. 1.66e+09. In the year 2001, what is the difference between the Taxes (in constant 2015 US$) in Morocco and Taxes (in constant 2015 US$) in Trinidad and Tobago?
Keep it short and to the point. 3.87e+09. In the year 2001, what is the difference between the Taxes (in constant 2015 US$) of Slovenia and Taxes (in constant 2015 US$) of Trinidad and Tobago?
Ensure brevity in your answer.  2.21e+09. In the year 2002, what is the difference between the Taxes (in constant 2015 US$) of Cuba and Taxes (in constant 2015 US$) of Morocco?
Keep it short and to the point. 1.04e+09. In the year 2002, what is the difference between the Taxes (in constant 2015 US$) of Cuba and Taxes (in constant 2015 US$) of Slovenia?
Your answer should be very brief. 2.56e+09. In the year 2002, what is the difference between the Taxes (in constant 2015 US$) of Cuba and Taxes (in constant 2015 US$) of Trinidad and Tobago?
Give a very brief answer. 5.16e+09. In the year 2002, what is the difference between the Taxes (in constant 2015 US$) of Morocco and Taxes (in constant 2015 US$) of Slovenia?
Provide a short and direct response. 1.53e+09. In the year 2002, what is the difference between the Taxes (in constant 2015 US$) in Morocco and Taxes (in constant 2015 US$) in Trinidad and Tobago?
Offer a terse response. 4.12e+09. In the year 2002, what is the difference between the Taxes (in constant 2015 US$) of Slovenia and Taxes (in constant 2015 US$) of Trinidad and Tobago?
Your answer should be compact. 2.59e+09. In the year 2003, what is the difference between the Taxes (in constant 2015 US$) in Cuba and Taxes (in constant 2015 US$) in Morocco?
Offer a terse response. 1.25e+09. In the year 2003, what is the difference between the Taxes (in constant 2015 US$) in Cuba and Taxes (in constant 2015 US$) in Slovenia?
Provide a short and direct response. 2.72e+09. In the year 2003, what is the difference between the Taxes (in constant 2015 US$) of Cuba and Taxes (in constant 2015 US$) of Trinidad and Tobago?
Keep it short and to the point. 6.04e+09. In the year 2003, what is the difference between the Taxes (in constant 2015 US$) in Morocco and Taxes (in constant 2015 US$) in Slovenia?
Your answer should be very brief. 1.47e+09. In the year 2003, what is the difference between the Taxes (in constant 2015 US$) in Morocco and Taxes (in constant 2015 US$) in Trinidad and Tobago?
Provide a succinct answer. 4.79e+09. In the year 2003, what is the difference between the Taxes (in constant 2015 US$) of Slovenia and Taxes (in constant 2015 US$) of Trinidad and Tobago?
Offer a terse response. 3.32e+09. What is the ratio of the Taxes (in constant 2015 US$) of Morocco in 1996 to that in 1997?
Your answer should be compact. 1.05. What is the ratio of the Taxes (in constant 2015 US$) of Slovenia in 1996 to that in 1997?
Provide a short and direct response. 1.12. What is the ratio of the Taxes (in constant 2015 US$) of Trinidad and Tobago in 1996 to that in 1997?
Provide a short and direct response. 0.91. What is the ratio of the Taxes (in constant 2015 US$) of Cuba in 1996 to that in 1998?
Your answer should be very brief. 1.1. What is the ratio of the Taxes (in constant 2015 US$) in Morocco in 1996 to that in 1998?
Make the answer very short. 1.04. What is the ratio of the Taxes (in constant 2015 US$) of Slovenia in 1996 to that in 1998?
Offer a terse response. 1.02. What is the ratio of the Taxes (in constant 2015 US$) of Trinidad and Tobago in 1996 to that in 1998?
Your answer should be very brief. 0.69. What is the ratio of the Taxes (in constant 2015 US$) of Cuba in 1996 to that in 1999?
Provide a short and direct response. 1.02. What is the ratio of the Taxes (in constant 2015 US$) of Morocco in 1996 to that in 1999?
Your answer should be compact. 1.04. What is the ratio of the Taxes (in constant 2015 US$) in Slovenia in 1996 to that in 1999?
Your response must be concise. 0.96. What is the ratio of the Taxes (in constant 2015 US$) in Trinidad and Tobago in 1996 to that in 1999?
Your answer should be very brief. 0.76. What is the ratio of the Taxes (in constant 2015 US$) of Cuba in 1996 to that in 2000?
Give a very brief answer. 1.04. What is the ratio of the Taxes (in constant 2015 US$) of Morocco in 1996 to that in 2000?
Ensure brevity in your answer.  1.14. What is the ratio of the Taxes (in constant 2015 US$) in Slovenia in 1996 to that in 2000?
Keep it short and to the point. 1.16. What is the ratio of the Taxes (in constant 2015 US$) of Trinidad and Tobago in 1996 to that in 2000?
Offer a very short reply. 0.73. What is the ratio of the Taxes (in constant 2015 US$) in Cuba in 1996 to that in 2001?
Make the answer very short. 1.04. What is the ratio of the Taxes (in constant 2015 US$) of Morocco in 1996 to that in 2001?
Your answer should be very brief. 1.11. What is the ratio of the Taxes (in constant 2015 US$) of Slovenia in 1996 to that in 2001?
Offer a terse response. 1.17. What is the ratio of the Taxes (in constant 2015 US$) in Trinidad and Tobago in 1996 to that in 2001?
Give a very brief answer. 0.67. What is the ratio of the Taxes (in constant 2015 US$) in Cuba in 1996 to that in 2002?
Offer a terse response. 0.91. What is the ratio of the Taxes (in constant 2015 US$) in Morocco in 1996 to that in 2002?
Provide a succinct answer. 1.04. What is the ratio of the Taxes (in constant 2015 US$) of Slovenia in 1996 to that in 2002?
Give a very brief answer. 1.01. What is the ratio of the Taxes (in constant 2015 US$) of Trinidad and Tobago in 1996 to that in 2002?
Your answer should be very brief. 0.61. What is the ratio of the Taxes (in constant 2015 US$) in Cuba in 1996 to that in 2003?
Provide a succinct answer. 0.78. What is the ratio of the Taxes (in constant 2015 US$) of Morocco in 1996 to that in 2003?
Offer a very short reply. 0.91. What is the ratio of the Taxes (in constant 2015 US$) in Slovenia in 1996 to that in 2003?
Your response must be concise. 0.81. What is the ratio of the Taxes (in constant 2015 US$) in Trinidad and Tobago in 1996 to that in 2003?
Your response must be concise. 0.63. What is the ratio of the Taxes (in constant 2015 US$) in Cuba in 1997 to that in 1998?
Your answer should be very brief. 1.08. What is the ratio of the Taxes (in constant 2015 US$) in Slovenia in 1997 to that in 1998?
Your response must be concise. 0.91. What is the ratio of the Taxes (in constant 2015 US$) of Trinidad and Tobago in 1997 to that in 1998?
Provide a succinct answer. 0.76. What is the ratio of the Taxes (in constant 2015 US$) of Slovenia in 1997 to that in 1999?
Your answer should be compact. 0.86. What is the ratio of the Taxes (in constant 2015 US$) in Trinidad and Tobago in 1997 to that in 1999?
Provide a short and direct response. 0.84. What is the ratio of the Taxes (in constant 2015 US$) in Cuba in 1997 to that in 2000?
Keep it short and to the point. 1.02. What is the ratio of the Taxes (in constant 2015 US$) of Morocco in 1997 to that in 2000?
Provide a short and direct response. 1.09. What is the ratio of the Taxes (in constant 2015 US$) in Slovenia in 1997 to that in 2000?
Provide a succinct answer. 1.04. What is the ratio of the Taxes (in constant 2015 US$) of Trinidad and Tobago in 1997 to that in 2000?
Keep it short and to the point. 0.81. What is the ratio of the Taxes (in constant 2015 US$) of Cuba in 1997 to that in 2001?
Your answer should be very brief. 1.02. What is the ratio of the Taxes (in constant 2015 US$) of Morocco in 1997 to that in 2001?
Make the answer very short. 1.06. What is the ratio of the Taxes (in constant 2015 US$) in Slovenia in 1997 to that in 2001?
Provide a short and direct response. 1.05. What is the ratio of the Taxes (in constant 2015 US$) of Trinidad and Tobago in 1997 to that in 2001?
Ensure brevity in your answer.  0.74. What is the ratio of the Taxes (in constant 2015 US$) in Cuba in 1997 to that in 2002?
Provide a succinct answer. 0.89. What is the ratio of the Taxes (in constant 2015 US$) in Morocco in 1997 to that in 2002?
Provide a succinct answer. 0.99. What is the ratio of the Taxes (in constant 2015 US$) of Slovenia in 1997 to that in 2002?
Provide a short and direct response. 0.9. What is the ratio of the Taxes (in constant 2015 US$) in Trinidad and Tobago in 1997 to that in 2002?
Give a very brief answer. 0.68. What is the ratio of the Taxes (in constant 2015 US$) of Cuba in 1997 to that in 2003?
Provide a succinct answer. 0.77. What is the ratio of the Taxes (in constant 2015 US$) in Morocco in 1997 to that in 2003?
Keep it short and to the point. 0.87. What is the ratio of the Taxes (in constant 2015 US$) in Slovenia in 1997 to that in 2003?
Your answer should be very brief. 0.72. What is the ratio of the Taxes (in constant 2015 US$) of Trinidad and Tobago in 1997 to that in 2003?
Your answer should be compact. 0.69. What is the ratio of the Taxes (in constant 2015 US$) in Cuba in 1998 to that in 1999?
Ensure brevity in your answer.  0.92. What is the ratio of the Taxes (in constant 2015 US$) in Slovenia in 1998 to that in 1999?
Your answer should be very brief. 0.94. What is the ratio of the Taxes (in constant 2015 US$) of Trinidad and Tobago in 1998 to that in 1999?
Provide a succinct answer. 1.11. What is the ratio of the Taxes (in constant 2015 US$) in Cuba in 1998 to that in 2000?
Make the answer very short. 0.95. What is the ratio of the Taxes (in constant 2015 US$) of Morocco in 1998 to that in 2000?
Your response must be concise. 1.1. What is the ratio of the Taxes (in constant 2015 US$) of Slovenia in 1998 to that in 2000?
Keep it short and to the point. 1.14. What is the ratio of the Taxes (in constant 2015 US$) of Trinidad and Tobago in 1998 to that in 2000?
Offer a terse response. 1.06. What is the ratio of the Taxes (in constant 2015 US$) of Cuba in 1998 to that in 2001?
Make the answer very short. 0.94. What is the ratio of the Taxes (in constant 2015 US$) of Morocco in 1998 to that in 2001?
Your response must be concise. 1.08. What is the ratio of the Taxes (in constant 2015 US$) of Slovenia in 1998 to that in 2001?
Provide a short and direct response. 1.15. What is the ratio of the Taxes (in constant 2015 US$) of Trinidad and Tobago in 1998 to that in 2001?
Ensure brevity in your answer.  0.98. What is the ratio of the Taxes (in constant 2015 US$) of Cuba in 1998 to that in 2002?
Your response must be concise. 0.82. What is the ratio of the Taxes (in constant 2015 US$) of Morocco in 1998 to that in 2002?
Your response must be concise. 1.01. What is the ratio of the Taxes (in constant 2015 US$) in Slovenia in 1998 to that in 2002?
Your response must be concise. 0.99. What is the ratio of the Taxes (in constant 2015 US$) in Trinidad and Tobago in 1998 to that in 2002?
Keep it short and to the point. 0.89. What is the ratio of the Taxes (in constant 2015 US$) in Cuba in 1998 to that in 2003?
Offer a terse response. 0.71. What is the ratio of the Taxes (in constant 2015 US$) of Morocco in 1998 to that in 2003?
Offer a very short reply. 0.88. What is the ratio of the Taxes (in constant 2015 US$) in Slovenia in 1998 to that in 2003?
Keep it short and to the point. 0.8. What is the ratio of the Taxes (in constant 2015 US$) in Trinidad and Tobago in 1998 to that in 2003?
Your response must be concise. 0.91. What is the ratio of the Taxes (in constant 2015 US$) of Cuba in 1999 to that in 2000?
Keep it short and to the point. 1.03. What is the ratio of the Taxes (in constant 2015 US$) in Morocco in 1999 to that in 2000?
Your answer should be very brief. 1.1. What is the ratio of the Taxes (in constant 2015 US$) of Slovenia in 1999 to that in 2000?
Offer a very short reply. 1.21. What is the ratio of the Taxes (in constant 2015 US$) of Cuba in 1999 to that in 2001?
Keep it short and to the point. 1.03. What is the ratio of the Taxes (in constant 2015 US$) in Morocco in 1999 to that in 2001?
Your response must be concise. 1.07. What is the ratio of the Taxes (in constant 2015 US$) in Slovenia in 1999 to that in 2001?
Make the answer very short. 1.22. What is the ratio of the Taxes (in constant 2015 US$) of Trinidad and Tobago in 1999 to that in 2001?
Provide a succinct answer. 0.88. What is the ratio of the Taxes (in constant 2015 US$) in Cuba in 1999 to that in 2002?
Provide a succinct answer. 0.89. What is the ratio of the Taxes (in constant 2015 US$) of Slovenia in 1999 to that in 2002?
Provide a short and direct response. 1.05. What is the ratio of the Taxes (in constant 2015 US$) in Trinidad and Tobago in 1999 to that in 2002?
Offer a terse response. 0.8. What is the ratio of the Taxes (in constant 2015 US$) of Cuba in 1999 to that in 2003?
Your response must be concise. 0.77. What is the ratio of the Taxes (in constant 2015 US$) in Morocco in 1999 to that in 2003?
Keep it short and to the point. 0.87. What is the ratio of the Taxes (in constant 2015 US$) of Slovenia in 1999 to that in 2003?
Your answer should be compact. 0.84. What is the ratio of the Taxes (in constant 2015 US$) of Trinidad and Tobago in 1999 to that in 2003?
Your answer should be compact. 0.82. What is the ratio of the Taxes (in constant 2015 US$) in Morocco in 2000 to that in 2001?
Provide a short and direct response. 0.98. What is the ratio of the Taxes (in constant 2015 US$) in Slovenia in 2000 to that in 2001?
Your answer should be compact. 1. What is the ratio of the Taxes (in constant 2015 US$) of Trinidad and Tobago in 2000 to that in 2001?
Keep it short and to the point. 0.92. What is the ratio of the Taxes (in constant 2015 US$) in Cuba in 2000 to that in 2002?
Offer a terse response. 0.87. What is the ratio of the Taxes (in constant 2015 US$) in Morocco in 2000 to that in 2002?
Ensure brevity in your answer.  0.92. What is the ratio of the Taxes (in constant 2015 US$) in Slovenia in 2000 to that in 2002?
Provide a succinct answer. 0.86. What is the ratio of the Taxes (in constant 2015 US$) of Trinidad and Tobago in 2000 to that in 2002?
Offer a very short reply. 0.84. What is the ratio of the Taxes (in constant 2015 US$) of Cuba in 2000 to that in 2003?
Your response must be concise. 0.75. What is the ratio of the Taxes (in constant 2015 US$) in Morocco in 2000 to that in 2003?
Make the answer very short. 0.8. What is the ratio of the Taxes (in constant 2015 US$) in Slovenia in 2000 to that in 2003?
Provide a short and direct response. 0.7. What is the ratio of the Taxes (in constant 2015 US$) of Trinidad and Tobago in 2000 to that in 2003?
Offer a very short reply. 0.86. What is the ratio of the Taxes (in constant 2015 US$) in Cuba in 2001 to that in 2002?
Give a very brief answer. 0.87. What is the ratio of the Taxes (in constant 2015 US$) in Slovenia in 2001 to that in 2002?
Offer a terse response. 0.86. What is the ratio of the Taxes (in constant 2015 US$) of Trinidad and Tobago in 2001 to that in 2002?
Give a very brief answer. 0.91. What is the ratio of the Taxes (in constant 2015 US$) in Cuba in 2001 to that in 2003?
Ensure brevity in your answer.  0.75. What is the ratio of the Taxes (in constant 2015 US$) in Morocco in 2001 to that in 2003?
Your answer should be very brief. 0.82. What is the ratio of the Taxes (in constant 2015 US$) of Slovenia in 2001 to that in 2003?
Make the answer very short. 0.69. What is the ratio of the Taxes (in constant 2015 US$) in Trinidad and Tobago in 2001 to that in 2003?
Your answer should be compact. 0.93. What is the ratio of the Taxes (in constant 2015 US$) of Cuba in 2002 to that in 2003?
Keep it short and to the point. 0.86. What is the ratio of the Taxes (in constant 2015 US$) in Morocco in 2002 to that in 2003?
Make the answer very short. 0.87. What is the ratio of the Taxes (in constant 2015 US$) in Slovenia in 2002 to that in 2003?
Your answer should be very brief. 0.81. What is the ratio of the Taxes (in constant 2015 US$) of Trinidad and Tobago in 2002 to that in 2003?
Offer a very short reply. 1.02. What is the difference between the highest and the second highest Taxes (in constant 2015 US$) of Cuba?
Offer a terse response. 8.76e+08. What is the difference between the highest and the second highest Taxes (in constant 2015 US$) of Morocco?
Your answer should be very brief. 4.63e+08. What is the difference between the highest and the second highest Taxes (in constant 2015 US$) of Slovenia?
Your answer should be compact. 5.81e+08. What is the difference between the highest and the second highest Taxes (in constant 2015 US$) of Trinidad and Tobago?
Provide a short and direct response. 8.65e+06. What is the difference between the highest and the lowest Taxes (in constant 2015 US$) in Cuba?
Keep it short and to the point. 1.86e+09. What is the difference between the highest and the lowest Taxes (in constant 2015 US$) of Morocco?
Your answer should be very brief. 1.04e+09. What is the difference between the highest and the lowest Taxes (in constant 2015 US$) in Slovenia?
Give a very brief answer. 1.14e+09. What is the difference between the highest and the lowest Taxes (in constant 2015 US$) of Trinidad and Tobago?
Offer a terse response. 1.49e+08. 